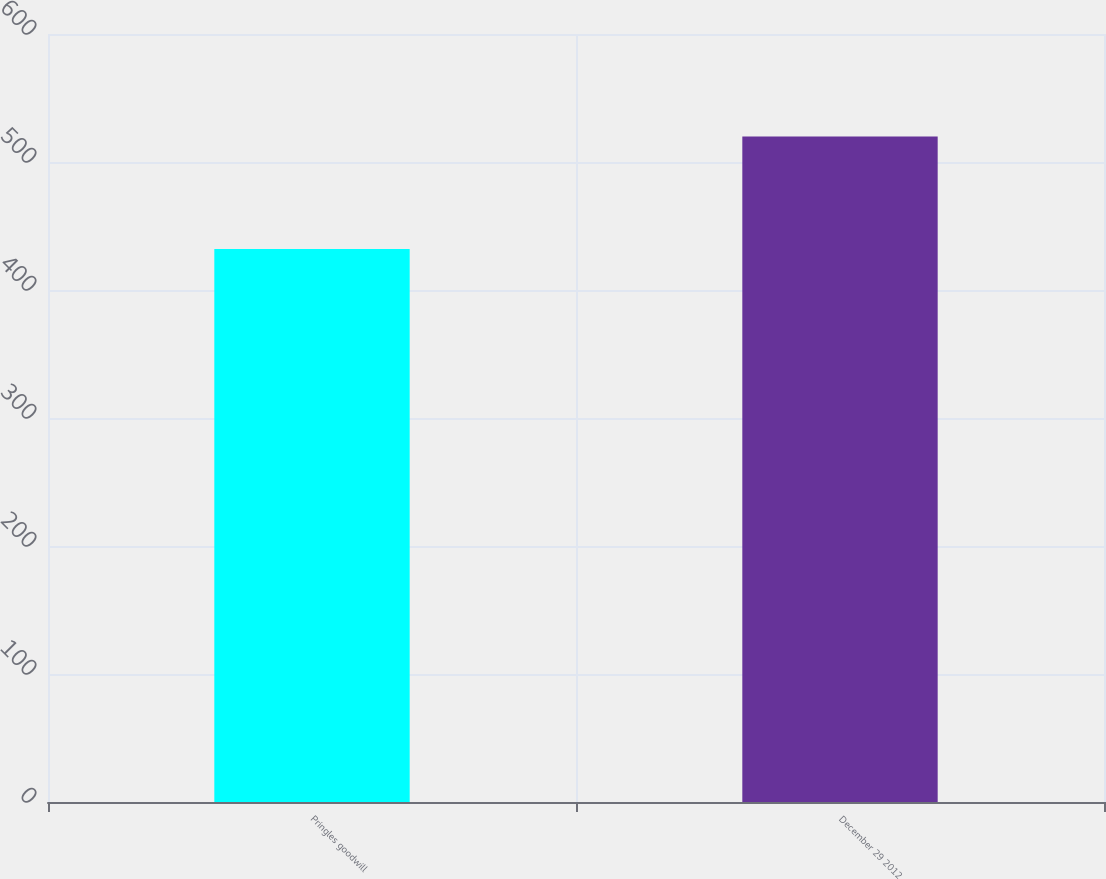Convert chart to OTSL. <chart><loc_0><loc_0><loc_500><loc_500><bar_chart><fcel>Pringles goodwill<fcel>December 29 2012<nl><fcel>432<fcel>520<nl></chart> 